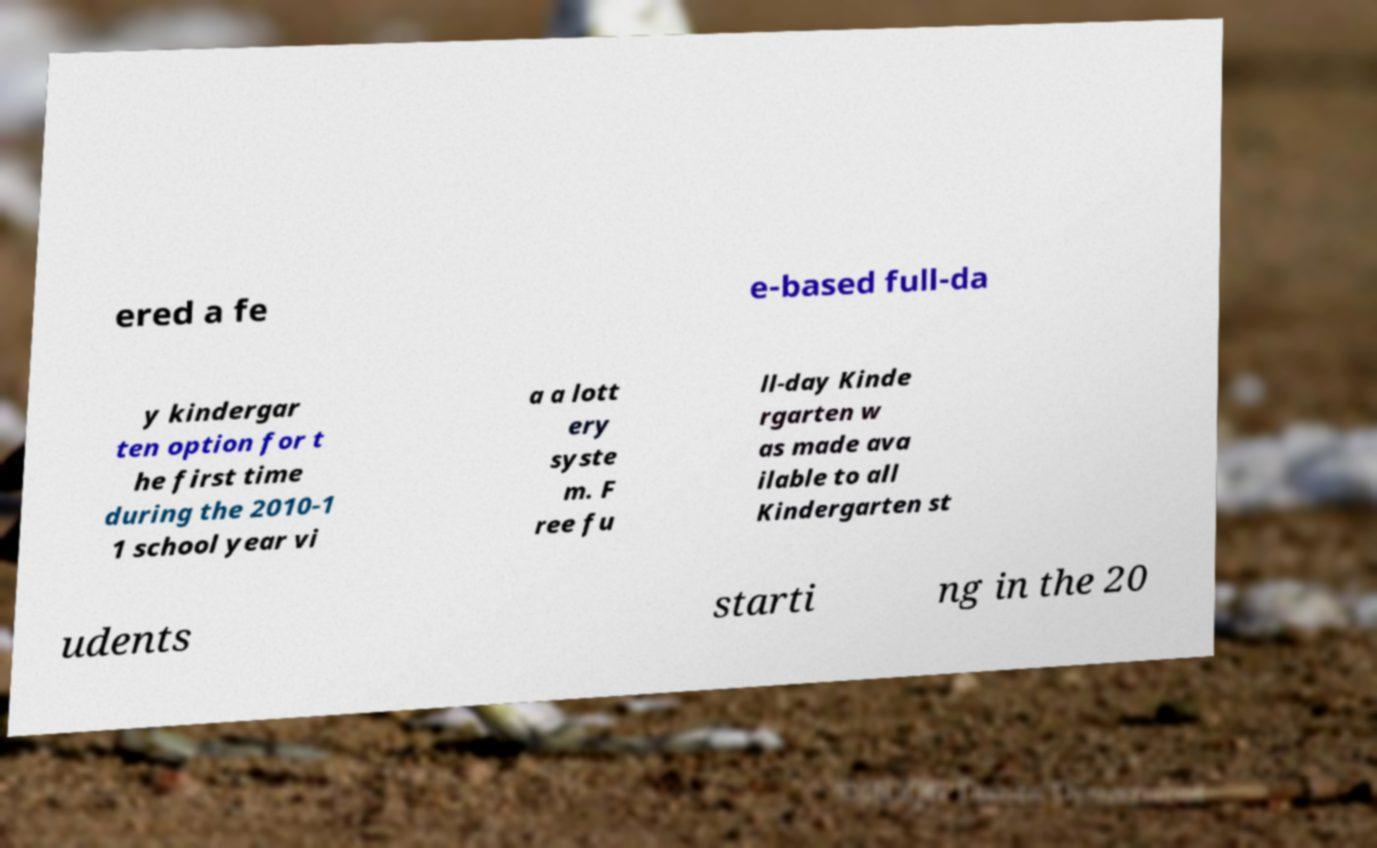Please identify and transcribe the text found in this image. ered a fe e-based full-da y kindergar ten option for t he first time during the 2010-1 1 school year vi a a lott ery syste m. F ree fu ll-day Kinde rgarten w as made ava ilable to all Kindergarten st udents starti ng in the 20 